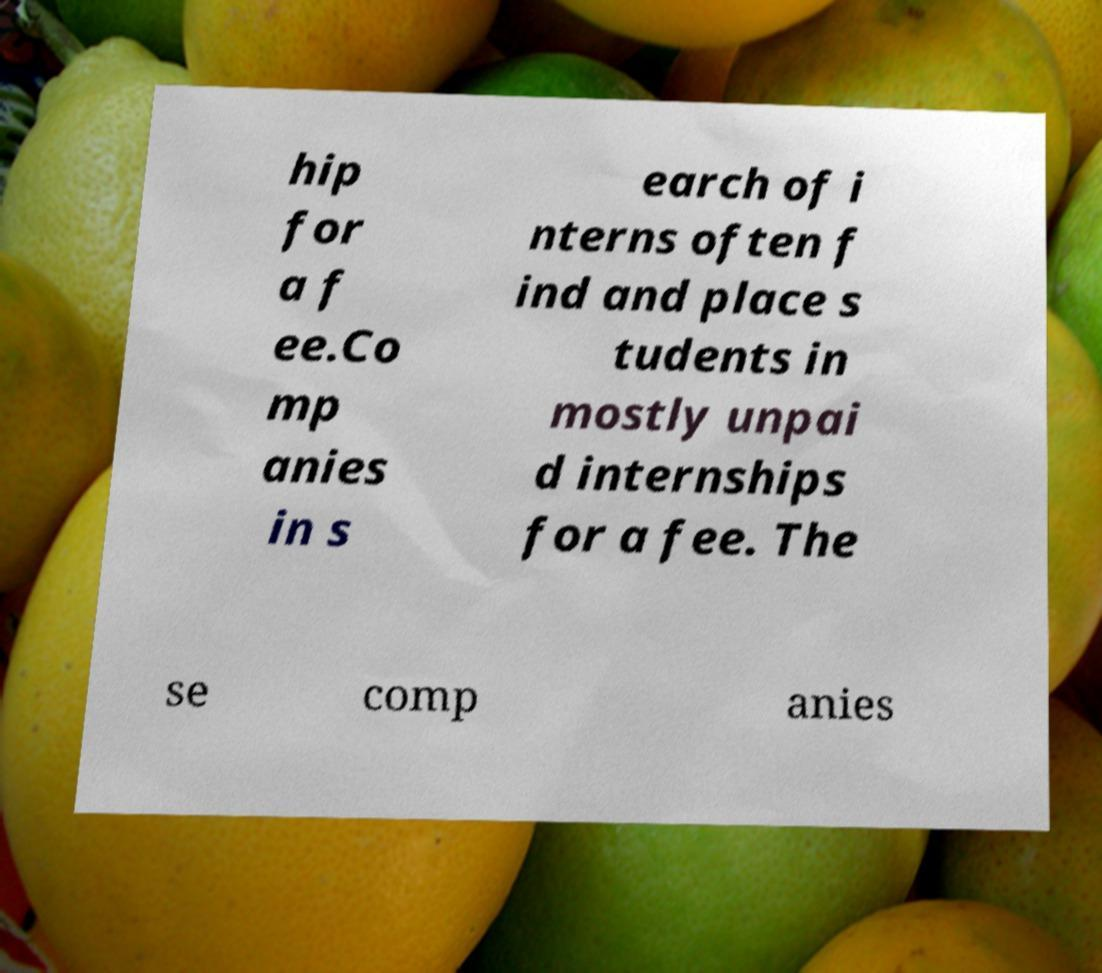There's text embedded in this image that I need extracted. Can you transcribe it verbatim? hip for a f ee.Co mp anies in s earch of i nterns often f ind and place s tudents in mostly unpai d internships for a fee. The se comp anies 